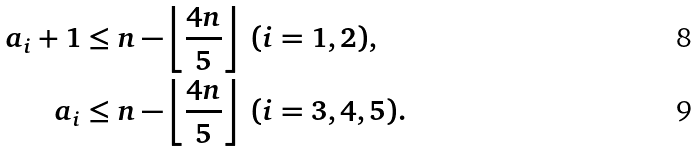<formula> <loc_0><loc_0><loc_500><loc_500>a _ { i } + 1 & \leq n - \left \lfloor \frac { 4 n } { 5 } \right \rfloor \ ( i = 1 , 2 ) , \\ a _ { i } & \leq n - \left \lfloor \frac { 4 n } { 5 } \right \rfloor \ ( i = 3 , 4 , 5 ) .</formula> 